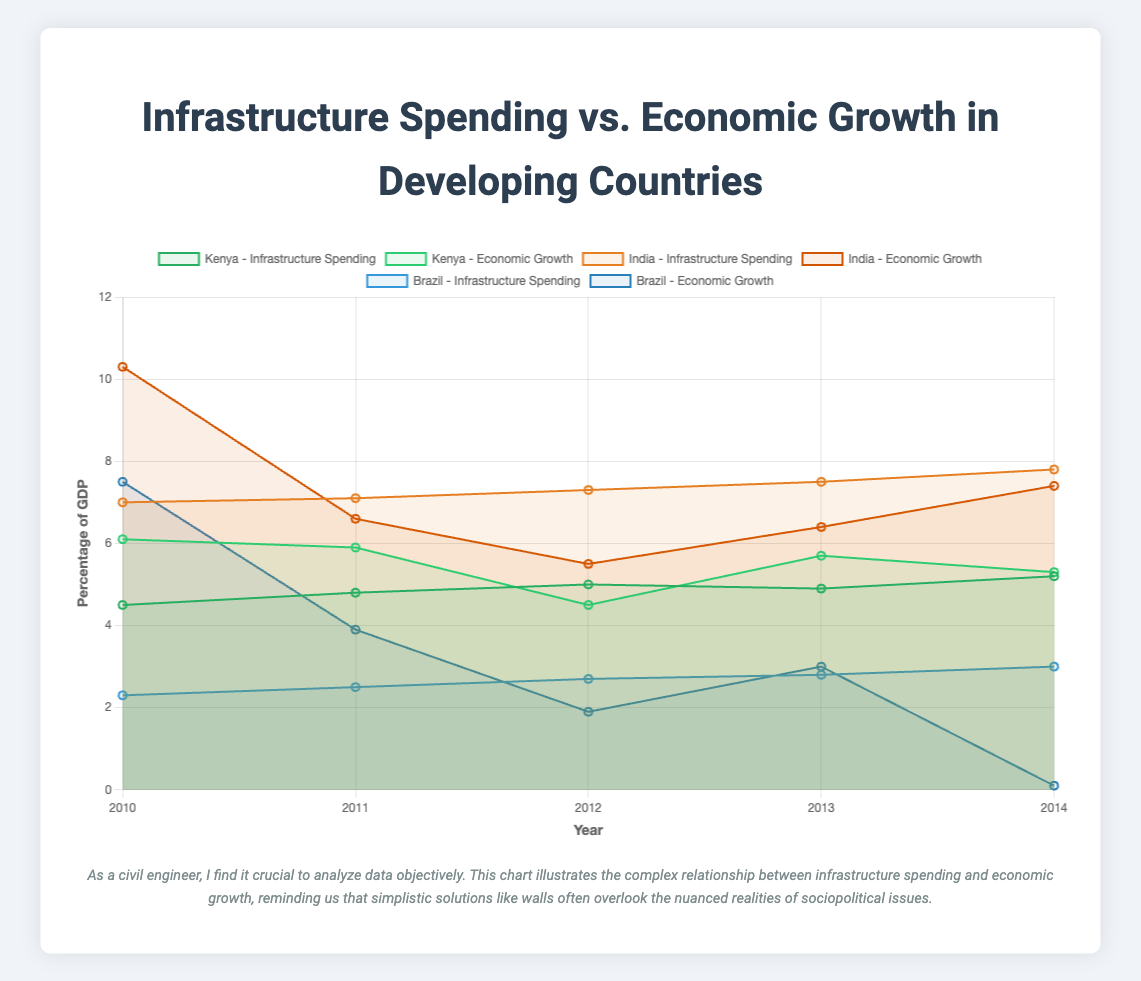Which country had the highest average economic growth over the period from 2010 to 2014? To calculate the average economic growth for each country, sum the annual growth rates from 2010 to 2014 and divide by the number of years (5). For Kenya: (6.1 + 5.9 + 4.5 + 5.7 + 5.3) / 5 = 5.5%. For India: (10.3 + 6.6 + 5.5 + 6.4 + 7.4) / 5 = 7.24%. For Brazil: (7.5 + 3.9 + 1.9 + 3.0 + 0.1) / 5 = 3.28%. India has the highest average economic growth.
Answer: India How did Kenya's economic growth rate change from 2010 to 2014? Look at the economic growth data points for Kenya. In 2010, the rate is 6.1%, and in 2014, it is 5.3%. Calculate the change as the difference between these two values: 5.3% - 6.1% = -0.8%. Kenya's economic growth rate decreased by 0.8%.
Answer: Decreased by 0.8% In which year did Brazil experience the largest drop in economic growth? Compare the annual economic growth rates for Brazil over consecutive years. The largest drop is from 2010 to 2011 (7.5% to 3.9%), which is a difference of 3.6%.
Answer: 2011 Did any country consistently increase its infrastructure spending from 2010 to 2014? Check the infrastructure spending data points for each country over the years. Only India shows a consistent increase: 7.0%, 7.1%, 7.3%, 7.5%, and 7.8%.
Answer: India In 2013, how much higher was Kenya's infrastructure spending as a percentage of GDP compared to Brazil? In 2013, Kenya's infrastructure spending was 4.9%, and Brazil's was 2.8%. Calculate the difference: 4.9% - 2.8% = 2.1%.
Answer: 2.1% Which country had the most fluctuating economic growth rates from 2010 to 2014? Consider the economic growth rate variance for each country. Kenya's range: 6.1% - 4.5% = 1.6%, India's range: 10.3% - 5.5% = 4.8%, Brazil's range: 7.5% - 0.1% = 7.4%. Brazil had the most fluctuation.
Answer: Brazil What was the difference between India's and Kenya's economic growth rates in 2010? India's economic growth rate in 2010 was 10.3%, and Kenya's was 6.1%. Calculate the difference: 10.3% - 6.1% = 4.2%.
Answer: 4.2% On average, how much did India spend on infrastructure as a percentage of GDP over these years? Sum India’s infrastructure spending from 2010 to 2014 and divide by 5. (7.0 + 7.1 + 7.3 + 7.5 + 7.8) / 5 = 7.34%.
Answer: 7.34% Did Brazil's economic growth rate ever surpass Kenya's between 2010 and 2014? Compare Brazil's and Kenya's annual economic growth rates. In 2010, Brazil's rate of 7.5% was higher than Kenya's 6.1%.
Answer: Yes 